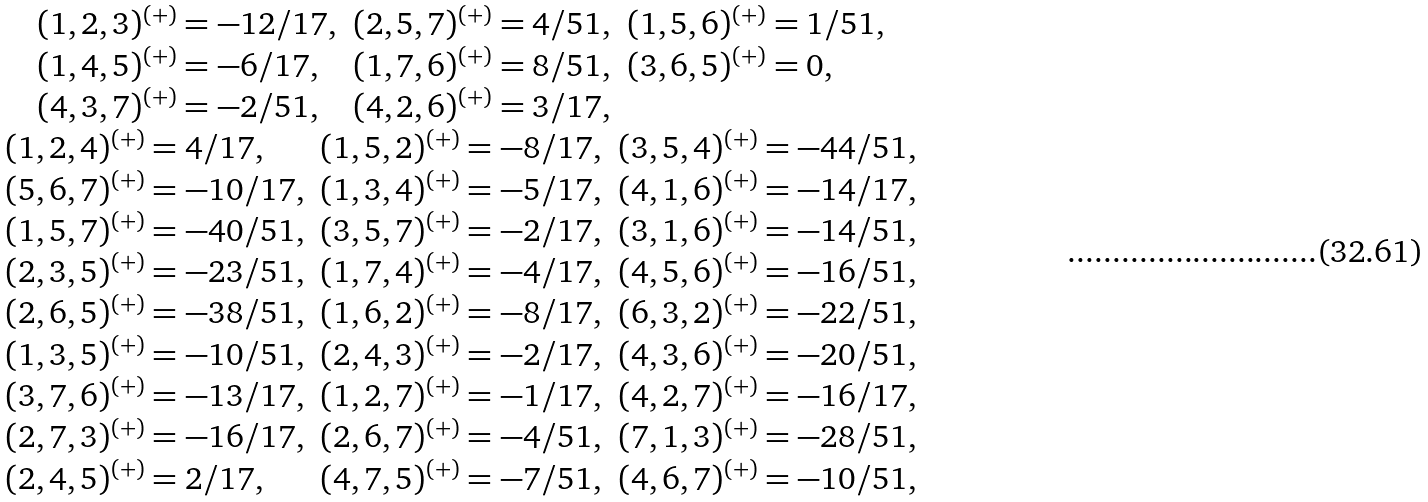<formula> <loc_0><loc_0><loc_500><loc_500>\begin{array} { c } \begin{array} { l l l } ( 1 , 2 , 3 ) ^ { ( + ) } = - 1 2 / 1 7 , & ( 2 , 5 , 7 ) ^ { ( + ) } = 4 / 5 1 , & ( 1 , 5 , 6 ) ^ { ( + ) } = 1 / 5 1 , \\ ( 1 , 4 , 5 ) ^ { ( + ) } = - 6 / 1 7 , & ( 1 , 7 , 6 ) ^ { ( + ) } = 8 / 5 1 , & ( 3 , 6 , 5 ) ^ { ( + ) } = 0 , \\ ( 4 , 3 , 7 ) ^ { ( + ) } = - 2 / 5 1 , & ( 4 , 2 , 6 ) ^ { ( + ) } = 3 / 1 7 , & \end{array} \\ \begin{array} { l l l } ( 1 , 2 , 4 ) ^ { ( + ) } = 4 / 1 7 , & ( 1 , 5 , 2 ) ^ { ( + ) } = - 8 / 1 7 , & ( 3 , 5 , 4 ) ^ { ( + ) } = - 4 4 / 5 1 , \\ ( 5 , 6 , 7 ) ^ { ( + ) } = - 1 0 / 1 7 , & ( 1 , 3 , 4 ) ^ { ( + ) } = - 5 / 1 7 , & ( 4 , 1 , 6 ) ^ { ( + ) } = - 1 4 / 1 7 , \\ ( 1 , 5 , 7 ) ^ { ( + ) } = - 4 0 / 5 1 , & ( 3 , 5 , 7 ) ^ { ( + ) } = - 2 / 1 7 , & ( 3 , 1 , 6 ) ^ { ( + ) } = - 1 4 / 5 1 , \\ ( 2 , 3 , 5 ) ^ { ( + ) } = - 2 3 / 5 1 , & ( 1 , 7 , 4 ) ^ { ( + ) } = - 4 / 1 7 , & ( 4 , 5 , 6 ) ^ { ( + ) } = - 1 6 / 5 1 , \\ ( 2 , 6 , 5 ) ^ { ( + ) } = - 3 8 / 5 1 , & ( 1 , 6 , 2 ) ^ { ( + ) } = - 8 / 1 7 , & ( 6 , 3 , 2 ) ^ { ( + ) } = - 2 2 / 5 1 , \\ ( 1 , 3 , 5 ) ^ { ( + ) } = - 1 0 / 5 1 , & ( 2 , 4 , 3 ) ^ { ( + ) } = - 2 / 1 7 , & ( 4 , 3 , 6 ) ^ { ( + ) } = - 2 0 / 5 1 , \\ ( 3 , 7 , 6 ) ^ { ( + ) } = - 1 3 / 1 7 , & ( 1 , 2 , 7 ) ^ { ( + ) } = - 1 / 1 7 , & ( 4 , 2 , 7 ) ^ { ( + ) } = - 1 6 / 1 7 , \\ ( 2 , 7 , 3 ) ^ { ( + ) } = - 1 6 / 1 7 , & ( 2 , 6 , 7 ) ^ { ( + ) } = - 4 / 5 1 , & ( 7 , 1 , 3 ) ^ { ( + ) } = - 2 8 / 5 1 , \\ ( 2 , 4 , 5 ) ^ { ( + ) } = 2 / 1 7 , & ( 4 , 7 , 5 ) ^ { ( + ) } = - 7 / 5 1 , & ( 4 , 6 , 7 ) ^ { ( + ) } = - 1 0 / 5 1 , \end{array} \end{array}</formula> 